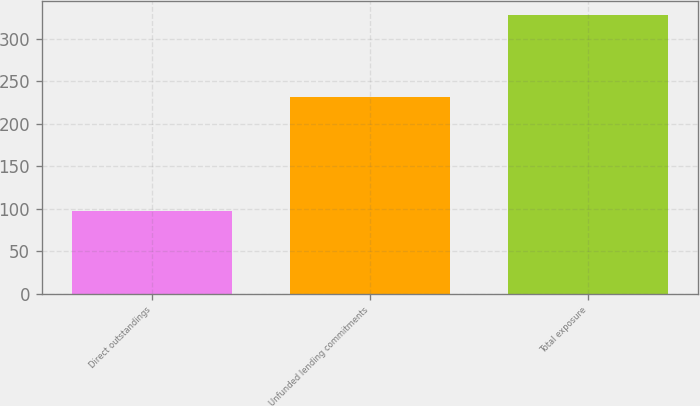Convert chart. <chart><loc_0><loc_0><loc_500><loc_500><bar_chart><fcel>Direct outstandings<fcel>Unfunded lending commitments<fcel>Total exposure<nl><fcel>97<fcel>231<fcel>328<nl></chart> 